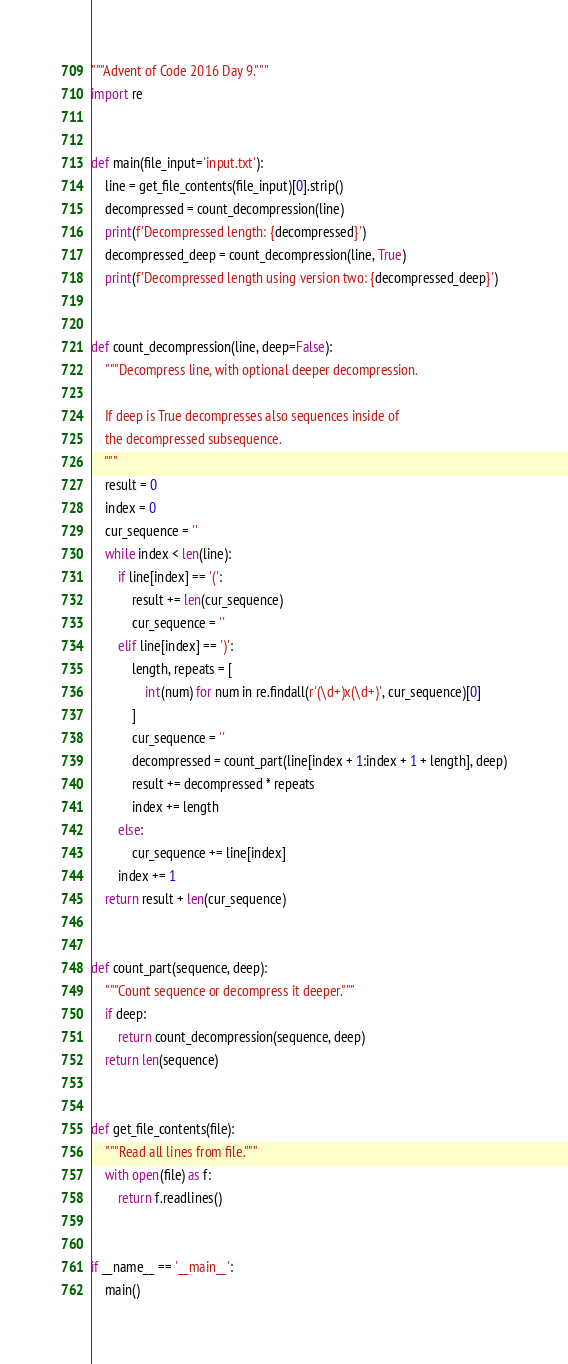Convert code to text. <code><loc_0><loc_0><loc_500><loc_500><_Python_>"""Advent of Code 2016 Day 9."""
import re


def main(file_input='input.txt'):
    line = get_file_contents(file_input)[0].strip()
    decompressed = count_decompression(line)
    print(f'Decompressed length: {decompressed}')
    decompressed_deep = count_decompression(line, True)
    print(f'Decompressed length using version two: {decompressed_deep}')


def count_decompression(line, deep=False):
    """Decompress line, with optional deeper decompression.

    If deep is True decompresses also sequences inside of
    the decompressed subsequence.
    """
    result = 0
    index = 0
    cur_sequence = ''
    while index < len(line):
        if line[index] == '(':
            result += len(cur_sequence)
            cur_sequence = ''
        elif line[index] == ')':
            length, repeats = [
                int(num) for num in re.findall(r'(\d+)x(\d+)', cur_sequence)[0]
            ]
            cur_sequence = ''
            decompressed = count_part(line[index + 1:index + 1 + length], deep)
            result += decompressed * repeats
            index += length
        else:
            cur_sequence += line[index]
        index += 1
    return result + len(cur_sequence)


def count_part(sequence, deep):
    """Count sequence or decompress it deeper."""
    if deep:
        return count_decompression(sequence, deep)
    return len(sequence)


def get_file_contents(file):
    """Read all lines from file."""
    with open(file) as f:
        return f.readlines()


if __name__ == '__main__':
    main()
</code> 